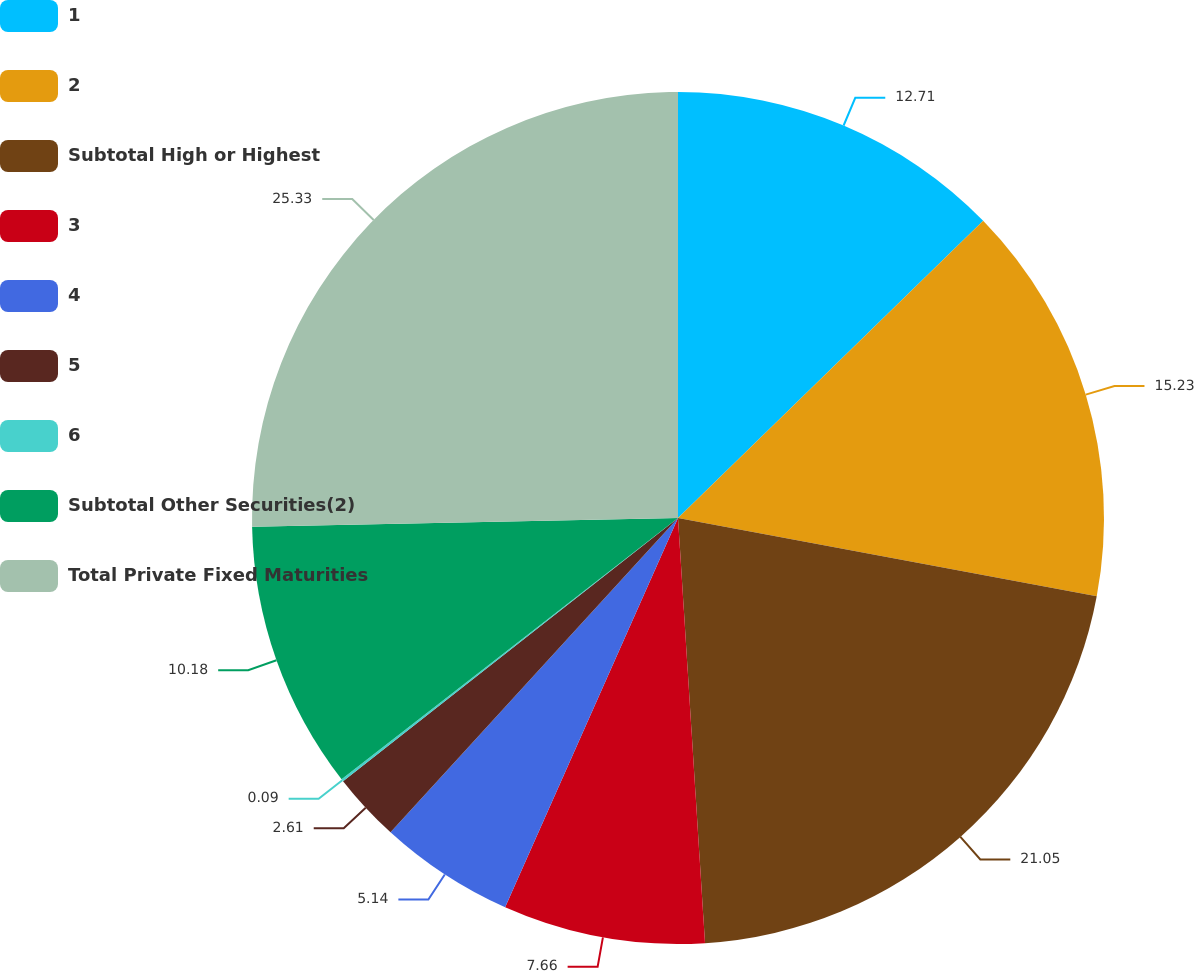<chart> <loc_0><loc_0><loc_500><loc_500><pie_chart><fcel>1<fcel>2<fcel>Subtotal High or Highest<fcel>3<fcel>4<fcel>5<fcel>6<fcel>Subtotal Other Securities(2)<fcel>Total Private Fixed Maturities<nl><fcel>12.71%<fcel>15.23%<fcel>21.05%<fcel>7.66%<fcel>5.14%<fcel>2.61%<fcel>0.09%<fcel>10.18%<fcel>25.33%<nl></chart> 